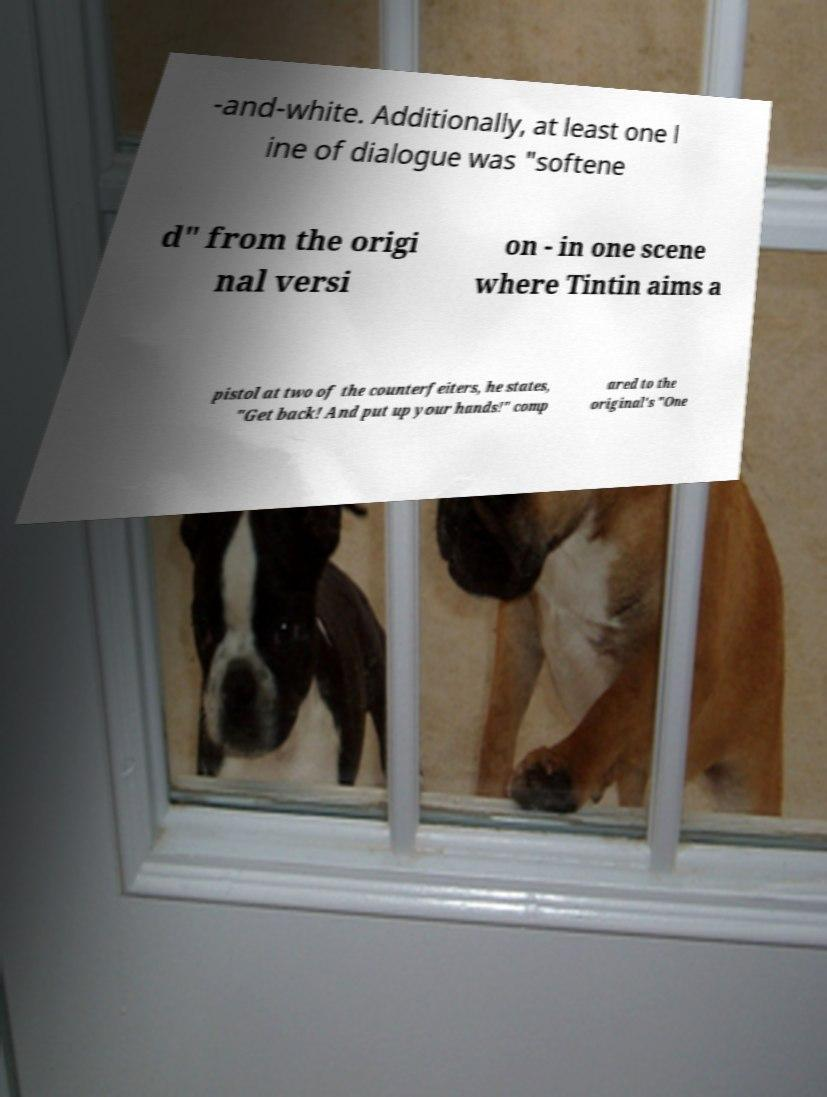Please read and relay the text visible in this image. What does it say? -and-white. Additionally, at least one l ine of dialogue was "softene d" from the origi nal versi on - in one scene where Tintin aims a pistol at two of the counterfeiters, he states, "Get back! And put up your hands!" comp ared to the original's "One 